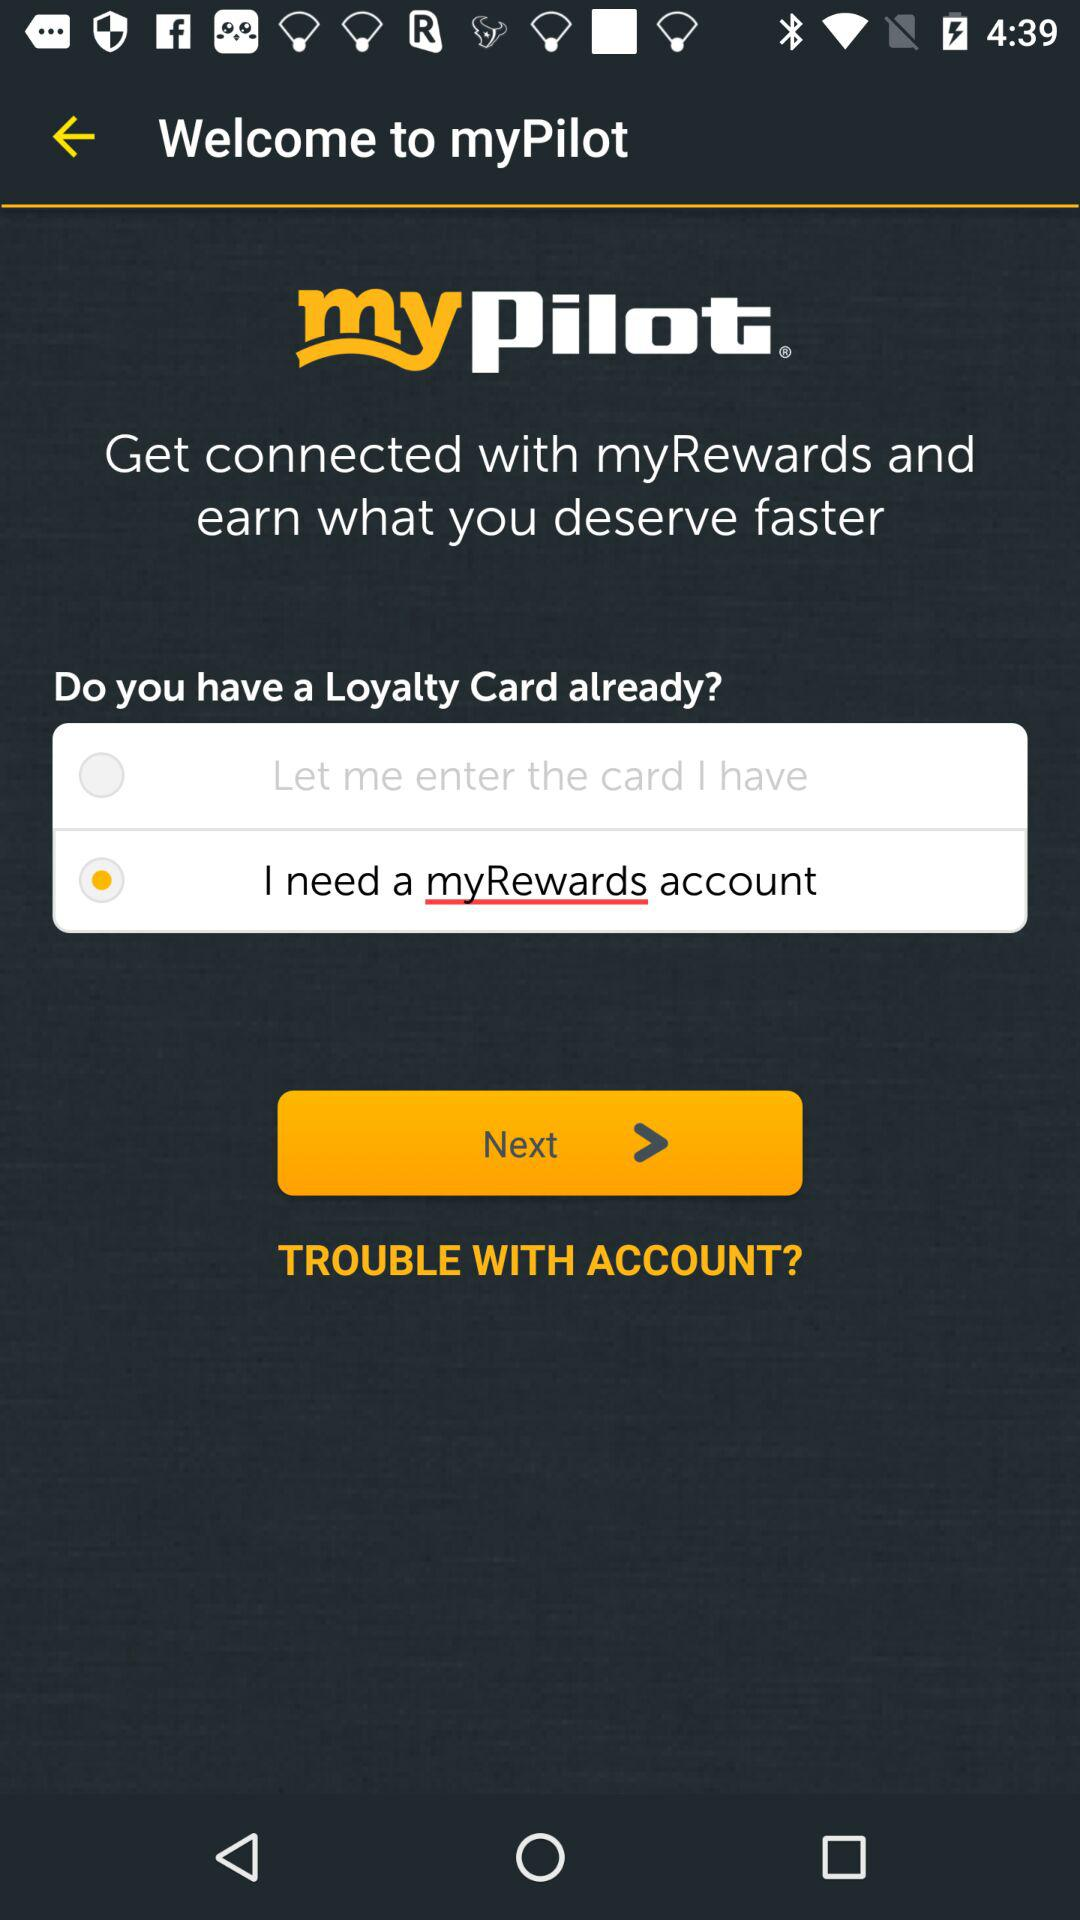What is the selected option? The selected option is "I need a myRewards account". 